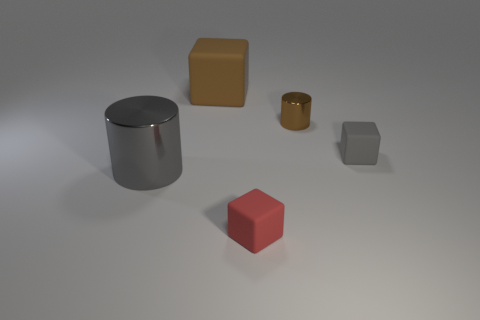What might be the purpose of these objects together like this? This collection of objects could serve multiple purposes. It can be a study in geometry, showcasing the variance in shapes - cylinders and cubes. It might also be a demonstration of lighting and material in a 3D rendering context, illustrating how different surfaces interact with light. Alternatively, it could be part of a visual composition exercise or a part of an art installation that explores the concept of minimalism in physical forms. 